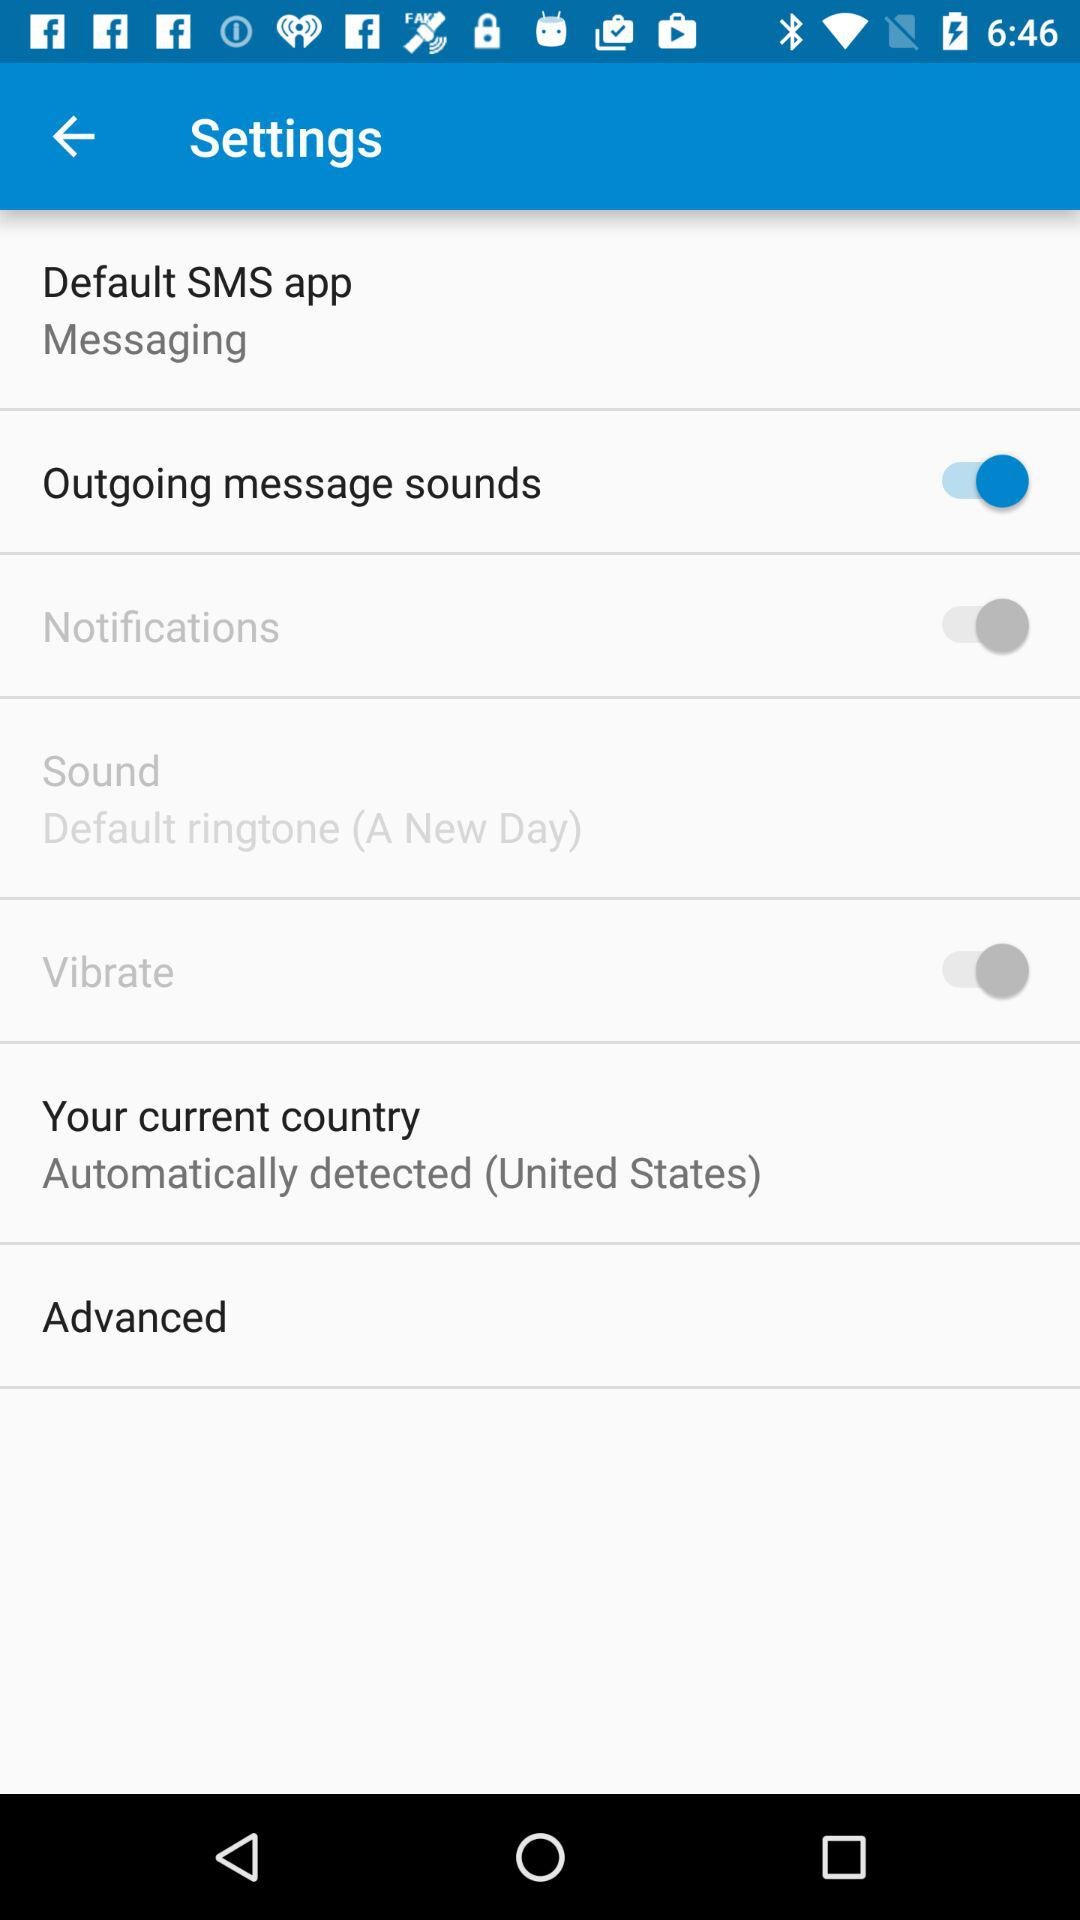Which settings are off?
When the provided information is insufficient, respond with <no answer>. <no answer> 